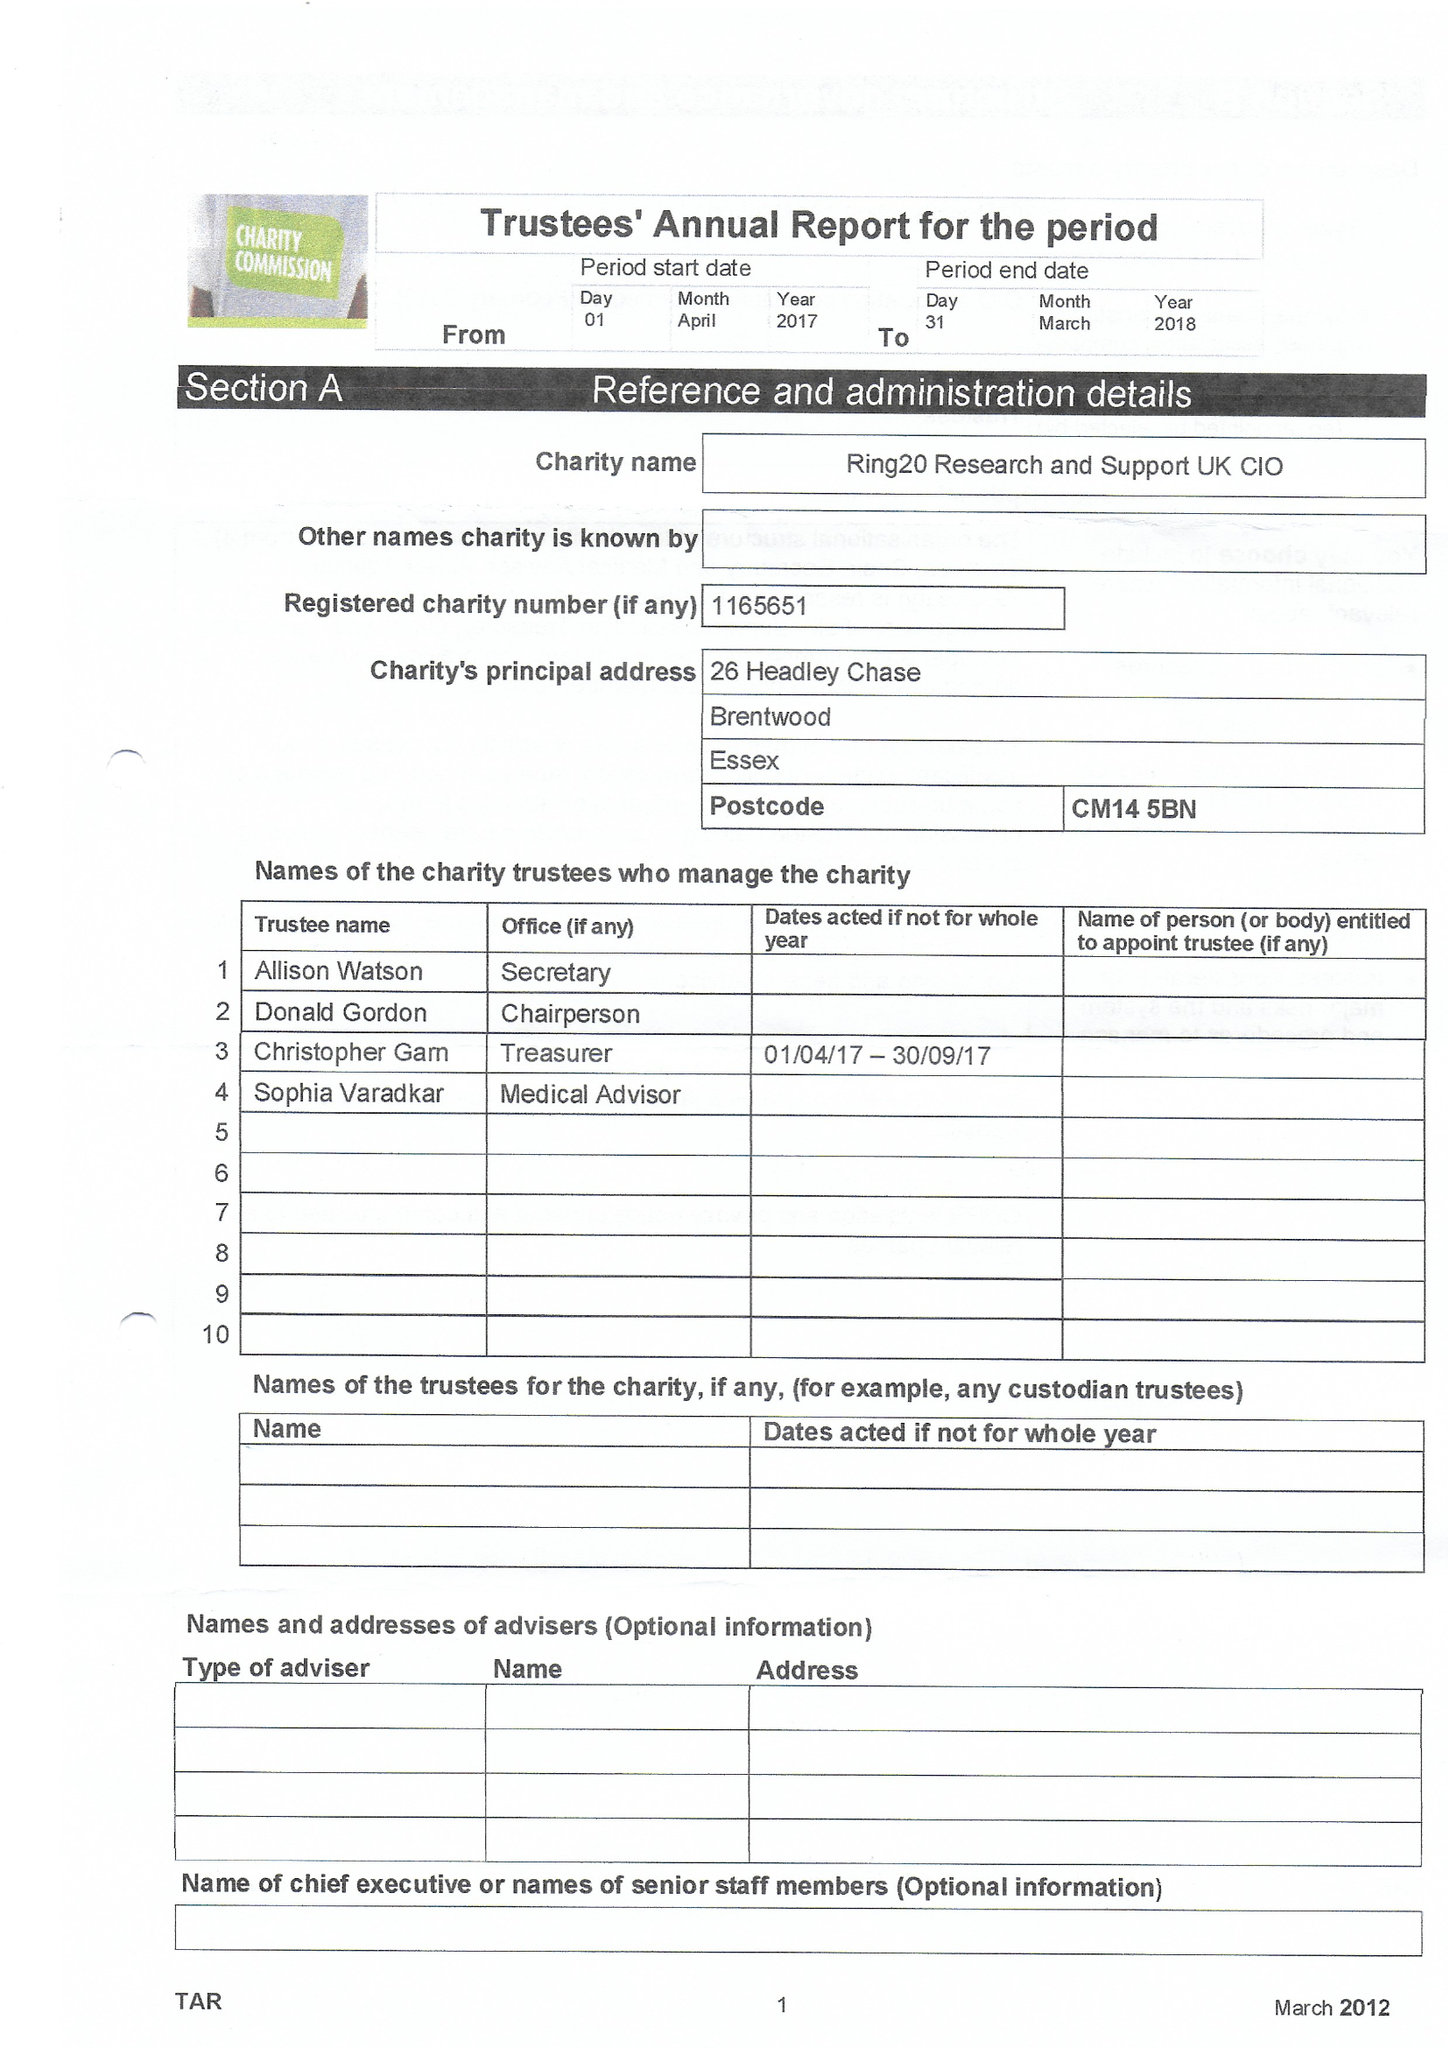What is the value for the charity_number?
Answer the question using a single word or phrase. 1165651 